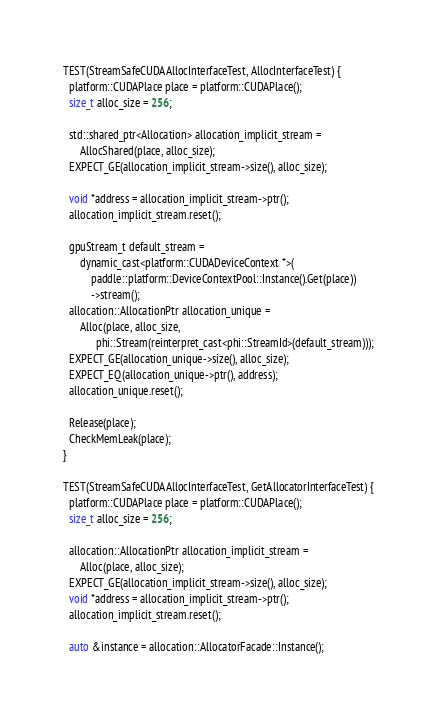<code> <loc_0><loc_0><loc_500><loc_500><_Cuda_>
TEST(StreamSafeCUDAAllocInterfaceTest, AllocInterfaceTest) {
  platform::CUDAPlace place = platform::CUDAPlace();
  size_t alloc_size = 256;

  std::shared_ptr<Allocation> allocation_implicit_stream =
      AllocShared(place, alloc_size);
  EXPECT_GE(allocation_implicit_stream->size(), alloc_size);

  void *address = allocation_implicit_stream->ptr();
  allocation_implicit_stream.reset();

  gpuStream_t default_stream =
      dynamic_cast<platform::CUDADeviceContext *>(
          paddle::platform::DeviceContextPool::Instance().Get(place))
          ->stream();
  allocation::AllocationPtr allocation_unique =
      Alloc(place, alloc_size,
            phi::Stream(reinterpret_cast<phi::StreamId>(default_stream)));
  EXPECT_GE(allocation_unique->size(), alloc_size);
  EXPECT_EQ(allocation_unique->ptr(), address);
  allocation_unique.reset();

  Release(place);
  CheckMemLeak(place);
}

TEST(StreamSafeCUDAAllocInterfaceTest, GetAllocatorInterfaceTest) {
  platform::CUDAPlace place = platform::CUDAPlace();
  size_t alloc_size = 256;

  allocation::AllocationPtr allocation_implicit_stream =
      Alloc(place, alloc_size);
  EXPECT_GE(allocation_implicit_stream->size(), alloc_size);
  void *address = allocation_implicit_stream->ptr();
  allocation_implicit_stream.reset();

  auto &instance = allocation::AllocatorFacade::Instance();</code> 